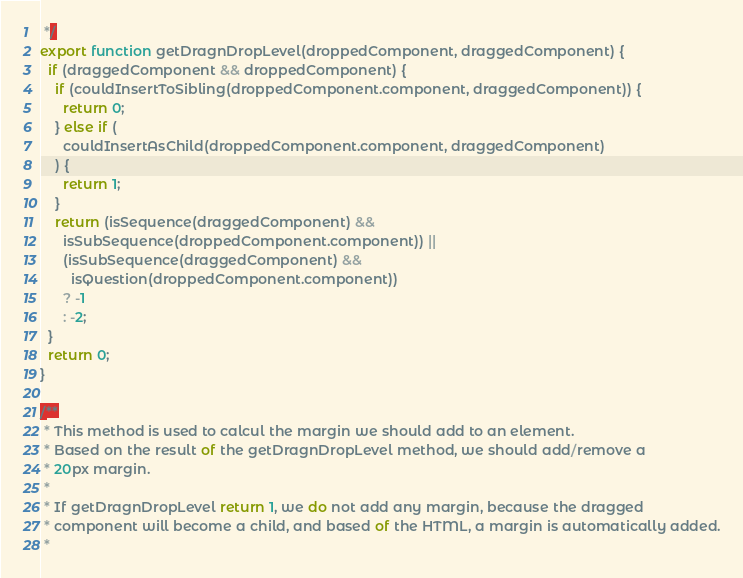Convert code to text. <code><loc_0><loc_0><loc_500><loc_500><_JavaScript_> */
export function getDragnDropLevel(droppedComponent, draggedComponent) {
  if (draggedComponent && droppedComponent) {
    if (couldInsertToSibling(droppedComponent.component, draggedComponent)) {
      return 0;
    } else if (
      couldInsertAsChild(droppedComponent.component, draggedComponent)
    ) {
      return 1;
    }
    return (isSequence(draggedComponent) &&
      isSubSequence(droppedComponent.component)) ||
      (isSubSequence(draggedComponent) &&
        isQuestion(droppedComponent.component))
      ? -1
      : -2;
  }
  return 0;
}

/**
 * This method is used to calcul the margin we should add to an element.
 * Based on the result of the getDragnDropLevel method, we should add/remove a
 * 20px margin.
 *
 * If getDragnDropLevel return 1, we do not add any margin, because the dragged
 * component will become a child, and based of the HTML, a margin is automatically added.
 *</code> 